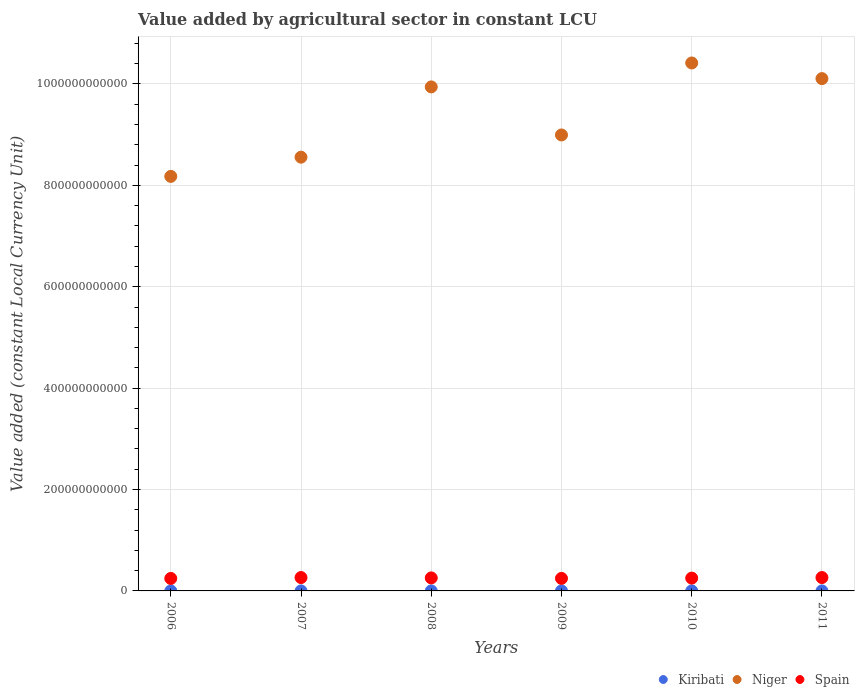What is the value added by agricultural sector in Kiribati in 2010?
Your response must be concise. 3.60e+07. Across all years, what is the maximum value added by agricultural sector in Niger?
Keep it short and to the point. 1.04e+12. Across all years, what is the minimum value added by agricultural sector in Niger?
Give a very brief answer. 8.18e+11. In which year was the value added by agricultural sector in Niger maximum?
Make the answer very short. 2010. In which year was the value added by agricultural sector in Kiribati minimum?
Your answer should be very brief. 2006. What is the total value added by agricultural sector in Kiribati in the graph?
Provide a succinct answer. 2.16e+08. What is the difference between the value added by agricultural sector in Kiribati in 2006 and that in 2008?
Provide a succinct answer. -6.91e+06. What is the difference between the value added by agricultural sector in Niger in 2009 and the value added by agricultural sector in Kiribati in 2007?
Provide a succinct answer. 8.99e+11. What is the average value added by agricultural sector in Niger per year?
Offer a terse response. 9.36e+11. In the year 2008, what is the difference between the value added by agricultural sector in Spain and value added by agricultural sector in Kiribati?
Keep it short and to the point. 2.56e+1. In how many years, is the value added by agricultural sector in Niger greater than 680000000000 LCU?
Offer a very short reply. 6. What is the ratio of the value added by agricultural sector in Kiribati in 2008 to that in 2010?
Provide a short and direct response. 1.04. Is the difference between the value added by agricultural sector in Spain in 2006 and 2008 greater than the difference between the value added by agricultural sector in Kiribati in 2006 and 2008?
Make the answer very short. No. What is the difference between the highest and the lowest value added by agricultural sector in Kiribati?
Your answer should be compact. 9.31e+06. In how many years, is the value added by agricultural sector in Kiribati greater than the average value added by agricultural sector in Kiribati taken over all years?
Your answer should be compact. 3. Is the sum of the value added by agricultural sector in Spain in 2010 and 2011 greater than the maximum value added by agricultural sector in Kiribati across all years?
Make the answer very short. Yes. Is it the case that in every year, the sum of the value added by agricultural sector in Niger and value added by agricultural sector in Kiribati  is greater than the value added by agricultural sector in Spain?
Offer a terse response. Yes. Does the value added by agricultural sector in Spain monotonically increase over the years?
Offer a very short reply. No. How many dotlines are there?
Your answer should be very brief. 3. How many years are there in the graph?
Ensure brevity in your answer.  6. What is the difference between two consecutive major ticks on the Y-axis?
Give a very brief answer. 2.00e+11. Are the values on the major ticks of Y-axis written in scientific E-notation?
Your response must be concise. No. Does the graph contain any zero values?
Give a very brief answer. No. Does the graph contain grids?
Your response must be concise. Yes. Where does the legend appear in the graph?
Ensure brevity in your answer.  Bottom right. How many legend labels are there?
Offer a very short reply. 3. How are the legend labels stacked?
Provide a succinct answer. Horizontal. What is the title of the graph?
Make the answer very short. Value added by agricultural sector in constant LCU. Does "Eritrea" appear as one of the legend labels in the graph?
Provide a succinct answer. No. What is the label or title of the X-axis?
Your response must be concise. Years. What is the label or title of the Y-axis?
Provide a succinct answer. Value added (constant Local Currency Unit). What is the Value added (constant Local Currency Unit) in Kiribati in 2006?
Offer a terse response. 3.07e+07. What is the Value added (constant Local Currency Unit) of Niger in 2006?
Make the answer very short. 8.18e+11. What is the Value added (constant Local Currency Unit) in Spain in 2006?
Provide a succinct answer. 2.46e+1. What is the Value added (constant Local Currency Unit) in Kiribati in 2007?
Offer a terse response. 3.50e+07. What is the Value added (constant Local Currency Unit) of Niger in 2007?
Your answer should be compact. 8.56e+11. What is the Value added (constant Local Currency Unit) of Spain in 2007?
Ensure brevity in your answer.  2.64e+1. What is the Value added (constant Local Currency Unit) of Kiribati in 2008?
Give a very brief answer. 3.76e+07. What is the Value added (constant Local Currency Unit) in Niger in 2008?
Your answer should be very brief. 9.94e+11. What is the Value added (constant Local Currency Unit) in Spain in 2008?
Provide a succinct answer. 2.57e+1. What is the Value added (constant Local Currency Unit) in Kiribati in 2009?
Provide a succinct answer. 3.71e+07. What is the Value added (constant Local Currency Unit) of Niger in 2009?
Give a very brief answer. 8.99e+11. What is the Value added (constant Local Currency Unit) in Spain in 2009?
Offer a very short reply. 2.47e+1. What is the Value added (constant Local Currency Unit) in Kiribati in 2010?
Provide a short and direct response. 3.60e+07. What is the Value added (constant Local Currency Unit) in Niger in 2010?
Make the answer very short. 1.04e+12. What is the Value added (constant Local Currency Unit) in Spain in 2010?
Offer a terse response. 2.53e+1. What is the Value added (constant Local Currency Unit) in Kiribati in 2011?
Give a very brief answer. 4.00e+07. What is the Value added (constant Local Currency Unit) in Niger in 2011?
Give a very brief answer. 1.01e+12. What is the Value added (constant Local Currency Unit) in Spain in 2011?
Ensure brevity in your answer.  2.64e+1. Across all years, what is the maximum Value added (constant Local Currency Unit) of Kiribati?
Your answer should be compact. 4.00e+07. Across all years, what is the maximum Value added (constant Local Currency Unit) of Niger?
Provide a short and direct response. 1.04e+12. Across all years, what is the maximum Value added (constant Local Currency Unit) in Spain?
Give a very brief answer. 2.64e+1. Across all years, what is the minimum Value added (constant Local Currency Unit) of Kiribati?
Your answer should be very brief. 3.07e+07. Across all years, what is the minimum Value added (constant Local Currency Unit) in Niger?
Give a very brief answer. 8.18e+11. Across all years, what is the minimum Value added (constant Local Currency Unit) in Spain?
Provide a short and direct response. 2.46e+1. What is the total Value added (constant Local Currency Unit) of Kiribati in the graph?
Your answer should be compact. 2.16e+08. What is the total Value added (constant Local Currency Unit) in Niger in the graph?
Your answer should be very brief. 5.62e+12. What is the total Value added (constant Local Currency Unit) in Spain in the graph?
Your answer should be very brief. 1.53e+11. What is the difference between the Value added (constant Local Currency Unit) in Kiribati in 2006 and that in 2007?
Your response must be concise. -4.28e+06. What is the difference between the Value added (constant Local Currency Unit) in Niger in 2006 and that in 2007?
Your response must be concise. -3.79e+1. What is the difference between the Value added (constant Local Currency Unit) in Spain in 2006 and that in 2007?
Offer a very short reply. -1.76e+09. What is the difference between the Value added (constant Local Currency Unit) of Kiribati in 2006 and that in 2008?
Make the answer very short. -6.91e+06. What is the difference between the Value added (constant Local Currency Unit) in Niger in 2006 and that in 2008?
Offer a very short reply. -1.77e+11. What is the difference between the Value added (constant Local Currency Unit) in Spain in 2006 and that in 2008?
Provide a succinct answer. -1.05e+09. What is the difference between the Value added (constant Local Currency Unit) in Kiribati in 2006 and that in 2009?
Ensure brevity in your answer.  -6.43e+06. What is the difference between the Value added (constant Local Currency Unit) of Niger in 2006 and that in 2009?
Offer a very short reply. -8.17e+1. What is the difference between the Value added (constant Local Currency Unit) in Spain in 2006 and that in 2009?
Your response must be concise. -1.14e+08. What is the difference between the Value added (constant Local Currency Unit) in Kiribati in 2006 and that in 2010?
Make the answer very short. -5.31e+06. What is the difference between the Value added (constant Local Currency Unit) of Niger in 2006 and that in 2010?
Offer a terse response. -2.24e+11. What is the difference between the Value added (constant Local Currency Unit) in Spain in 2006 and that in 2010?
Your answer should be very brief. -6.43e+08. What is the difference between the Value added (constant Local Currency Unit) in Kiribati in 2006 and that in 2011?
Offer a very short reply. -9.31e+06. What is the difference between the Value added (constant Local Currency Unit) of Niger in 2006 and that in 2011?
Your answer should be very brief. -1.93e+11. What is the difference between the Value added (constant Local Currency Unit) in Spain in 2006 and that in 2011?
Give a very brief answer. -1.76e+09. What is the difference between the Value added (constant Local Currency Unit) in Kiribati in 2007 and that in 2008?
Make the answer very short. -2.63e+06. What is the difference between the Value added (constant Local Currency Unit) in Niger in 2007 and that in 2008?
Offer a terse response. -1.39e+11. What is the difference between the Value added (constant Local Currency Unit) of Spain in 2007 and that in 2008?
Provide a short and direct response. 7.15e+08. What is the difference between the Value added (constant Local Currency Unit) of Kiribati in 2007 and that in 2009?
Offer a terse response. -2.15e+06. What is the difference between the Value added (constant Local Currency Unit) of Niger in 2007 and that in 2009?
Provide a short and direct response. -4.38e+1. What is the difference between the Value added (constant Local Currency Unit) of Spain in 2007 and that in 2009?
Make the answer very short. 1.65e+09. What is the difference between the Value added (constant Local Currency Unit) in Kiribati in 2007 and that in 2010?
Your response must be concise. -1.02e+06. What is the difference between the Value added (constant Local Currency Unit) of Niger in 2007 and that in 2010?
Your response must be concise. -1.86e+11. What is the difference between the Value added (constant Local Currency Unit) in Spain in 2007 and that in 2010?
Offer a very short reply. 1.12e+09. What is the difference between the Value added (constant Local Currency Unit) of Kiribati in 2007 and that in 2011?
Make the answer very short. -5.02e+06. What is the difference between the Value added (constant Local Currency Unit) of Niger in 2007 and that in 2011?
Your answer should be very brief. -1.55e+11. What is the difference between the Value added (constant Local Currency Unit) of Kiribati in 2008 and that in 2009?
Offer a very short reply. 4.78e+05. What is the difference between the Value added (constant Local Currency Unit) in Niger in 2008 and that in 2009?
Give a very brief answer. 9.48e+1. What is the difference between the Value added (constant Local Currency Unit) of Spain in 2008 and that in 2009?
Your response must be concise. 9.32e+08. What is the difference between the Value added (constant Local Currency Unit) in Kiribati in 2008 and that in 2010?
Provide a succinct answer. 1.60e+06. What is the difference between the Value added (constant Local Currency Unit) of Niger in 2008 and that in 2010?
Keep it short and to the point. -4.72e+1. What is the difference between the Value added (constant Local Currency Unit) in Spain in 2008 and that in 2010?
Offer a very short reply. 4.03e+08. What is the difference between the Value added (constant Local Currency Unit) in Kiribati in 2008 and that in 2011?
Your response must be concise. -2.40e+06. What is the difference between the Value added (constant Local Currency Unit) of Niger in 2008 and that in 2011?
Offer a very short reply. -1.64e+1. What is the difference between the Value added (constant Local Currency Unit) in Spain in 2008 and that in 2011?
Give a very brief answer. -7.17e+08. What is the difference between the Value added (constant Local Currency Unit) of Kiribati in 2009 and that in 2010?
Offer a very short reply. 1.13e+06. What is the difference between the Value added (constant Local Currency Unit) of Niger in 2009 and that in 2010?
Your answer should be compact. -1.42e+11. What is the difference between the Value added (constant Local Currency Unit) in Spain in 2009 and that in 2010?
Ensure brevity in your answer.  -5.29e+08. What is the difference between the Value added (constant Local Currency Unit) in Kiribati in 2009 and that in 2011?
Your answer should be very brief. -2.87e+06. What is the difference between the Value added (constant Local Currency Unit) of Niger in 2009 and that in 2011?
Ensure brevity in your answer.  -1.11e+11. What is the difference between the Value added (constant Local Currency Unit) of Spain in 2009 and that in 2011?
Offer a terse response. -1.65e+09. What is the difference between the Value added (constant Local Currency Unit) in Kiribati in 2010 and that in 2011?
Provide a short and direct response. -4.00e+06. What is the difference between the Value added (constant Local Currency Unit) in Niger in 2010 and that in 2011?
Offer a terse response. 3.09e+1. What is the difference between the Value added (constant Local Currency Unit) in Spain in 2010 and that in 2011?
Offer a terse response. -1.12e+09. What is the difference between the Value added (constant Local Currency Unit) of Kiribati in 2006 and the Value added (constant Local Currency Unit) of Niger in 2007?
Offer a terse response. -8.56e+11. What is the difference between the Value added (constant Local Currency Unit) of Kiribati in 2006 and the Value added (constant Local Currency Unit) of Spain in 2007?
Keep it short and to the point. -2.63e+1. What is the difference between the Value added (constant Local Currency Unit) of Niger in 2006 and the Value added (constant Local Currency Unit) of Spain in 2007?
Provide a succinct answer. 7.91e+11. What is the difference between the Value added (constant Local Currency Unit) in Kiribati in 2006 and the Value added (constant Local Currency Unit) in Niger in 2008?
Offer a very short reply. -9.94e+11. What is the difference between the Value added (constant Local Currency Unit) in Kiribati in 2006 and the Value added (constant Local Currency Unit) in Spain in 2008?
Offer a very short reply. -2.56e+1. What is the difference between the Value added (constant Local Currency Unit) in Niger in 2006 and the Value added (constant Local Currency Unit) in Spain in 2008?
Ensure brevity in your answer.  7.92e+11. What is the difference between the Value added (constant Local Currency Unit) in Kiribati in 2006 and the Value added (constant Local Currency Unit) in Niger in 2009?
Give a very brief answer. -8.99e+11. What is the difference between the Value added (constant Local Currency Unit) of Kiribati in 2006 and the Value added (constant Local Currency Unit) of Spain in 2009?
Offer a terse response. -2.47e+1. What is the difference between the Value added (constant Local Currency Unit) in Niger in 2006 and the Value added (constant Local Currency Unit) in Spain in 2009?
Offer a very short reply. 7.93e+11. What is the difference between the Value added (constant Local Currency Unit) of Kiribati in 2006 and the Value added (constant Local Currency Unit) of Niger in 2010?
Keep it short and to the point. -1.04e+12. What is the difference between the Value added (constant Local Currency Unit) in Kiribati in 2006 and the Value added (constant Local Currency Unit) in Spain in 2010?
Give a very brief answer. -2.52e+1. What is the difference between the Value added (constant Local Currency Unit) of Niger in 2006 and the Value added (constant Local Currency Unit) of Spain in 2010?
Offer a terse response. 7.92e+11. What is the difference between the Value added (constant Local Currency Unit) of Kiribati in 2006 and the Value added (constant Local Currency Unit) of Niger in 2011?
Ensure brevity in your answer.  -1.01e+12. What is the difference between the Value added (constant Local Currency Unit) of Kiribati in 2006 and the Value added (constant Local Currency Unit) of Spain in 2011?
Offer a very short reply. -2.63e+1. What is the difference between the Value added (constant Local Currency Unit) in Niger in 2006 and the Value added (constant Local Currency Unit) in Spain in 2011?
Offer a very short reply. 7.91e+11. What is the difference between the Value added (constant Local Currency Unit) of Kiribati in 2007 and the Value added (constant Local Currency Unit) of Niger in 2008?
Give a very brief answer. -9.94e+11. What is the difference between the Value added (constant Local Currency Unit) of Kiribati in 2007 and the Value added (constant Local Currency Unit) of Spain in 2008?
Provide a succinct answer. -2.56e+1. What is the difference between the Value added (constant Local Currency Unit) of Niger in 2007 and the Value added (constant Local Currency Unit) of Spain in 2008?
Offer a very short reply. 8.30e+11. What is the difference between the Value added (constant Local Currency Unit) in Kiribati in 2007 and the Value added (constant Local Currency Unit) in Niger in 2009?
Your answer should be very brief. -8.99e+11. What is the difference between the Value added (constant Local Currency Unit) in Kiribati in 2007 and the Value added (constant Local Currency Unit) in Spain in 2009?
Your answer should be very brief. -2.47e+1. What is the difference between the Value added (constant Local Currency Unit) of Niger in 2007 and the Value added (constant Local Currency Unit) of Spain in 2009?
Give a very brief answer. 8.31e+11. What is the difference between the Value added (constant Local Currency Unit) in Kiribati in 2007 and the Value added (constant Local Currency Unit) in Niger in 2010?
Provide a succinct answer. -1.04e+12. What is the difference between the Value added (constant Local Currency Unit) in Kiribati in 2007 and the Value added (constant Local Currency Unit) in Spain in 2010?
Offer a very short reply. -2.52e+1. What is the difference between the Value added (constant Local Currency Unit) in Niger in 2007 and the Value added (constant Local Currency Unit) in Spain in 2010?
Offer a very short reply. 8.30e+11. What is the difference between the Value added (constant Local Currency Unit) in Kiribati in 2007 and the Value added (constant Local Currency Unit) in Niger in 2011?
Give a very brief answer. -1.01e+12. What is the difference between the Value added (constant Local Currency Unit) of Kiribati in 2007 and the Value added (constant Local Currency Unit) of Spain in 2011?
Provide a succinct answer. -2.63e+1. What is the difference between the Value added (constant Local Currency Unit) in Niger in 2007 and the Value added (constant Local Currency Unit) in Spain in 2011?
Your response must be concise. 8.29e+11. What is the difference between the Value added (constant Local Currency Unit) in Kiribati in 2008 and the Value added (constant Local Currency Unit) in Niger in 2009?
Offer a terse response. -8.99e+11. What is the difference between the Value added (constant Local Currency Unit) of Kiribati in 2008 and the Value added (constant Local Currency Unit) of Spain in 2009?
Your answer should be compact. -2.47e+1. What is the difference between the Value added (constant Local Currency Unit) of Niger in 2008 and the Value added (constant Local Currency Unit) of Spain in 2009?
Your answer should be very brief. 9.69e+11. What is the difference between the Value added (constant Local Currency Unit) in Kiribati in 2008 and the Value added (constant Local Currency Unit) in Niger in 2010?
Your answer should be compact. -1.04e+12. What is the difference between the Value added (constant Local Currency Unit) in Kiribati in 2008 and the Value added (constant Local Currency Unit) in Spain in 2010?
Make the answer very short. -2.52e+1. What is the difference between the Value added (constant Local Currency Unit) of Niger in 2008 and the Value added (constant Local Currency Unit) of Spain in 2010?
Offer a terse response. 9.69e+11. What is the difference between the Value added (constant Local Currency Unit) in Kiribati in 2008 and the Value added (constant Local Currency Unit) in Niger in 2011?
Your answer should be very brief. -1.01e+12. What is the difference between the Value added (constant Local Currency Unit) of Kiribati in 2008 and the Value added (constant Local Currency Unit) of Spain in 2011?
Your answer should be compact. -2.63e+1. What is the difference between the Value added (constant Local Currency Unit) in Niger in 2008 and the Value added (constant Local Currency Unit) in Spain in 2011?
Make the answer very short. 9.68e+11. What is the difference between the Value added (constant Local Currency Unit) in Kiribati in 2009 and the Value added (constant Local Currency Unit) in Niger in 2010?
Provide a succinct answer. -1.04e+12. What is the difference between the Value added (constant Local Currency Unit) of Kiribati in 2009 and the Value added (constant Local Currency Unit) of Spain in 2010?
Your response must be concise. -2.52e+1. What is the difference between the Value added (constant Local Currency Unit) in Niger in 2009 and the Value added (constant Local Currency Unit) in Spain in 2010?
Give a very brief answer. 8.74e+11. What is the difference between the Value added (constant Local Currency Unit) in Kiribati in 2009 and the Value added (constant Local Currency Unit) in Niger in 2011?
Offer a terse response. -1.01e+12. What is the difference between the Value added (constant Local Currency Unit) in Kiribati in 2009 and the Value added (constant Local Currency Unit) in Spain in 2011?
Your answer should be compact. -2.63e+1. What is the difference between the Value added (constant Local Currency Unit) of Niger in 2009 and the Value added (constant Local Currency Unit) of Spain in 2011?
Your answer should be very brief. 8.73e+11. What is the difference between the Value added (constant Local Currency Unit) of Kiribati in 2010 and the Value added (constant Local Currency Unit) of Niger in 2011?
Provide a short and direct response. -1.01e+12. What is the difference between the Value added (constant Local Currency Unit) in Kiribati in 2010 and the Value added (constant Local Currency Unit) in Spain in 2011?
Ensure brevity in your answer.  -2.63e+1. What is the difference between the Value added (constant Local Currency Unit) in Niger in 2010 and the Value added (constant Local Currency Unit) in Spain in 2011?
Make the answer very short. 1.02e+12. What is the average Value added (constant Local Currency Unit) of Kiribati per year?
Your answer should be very brief. 3.61e+07. What is the average Value added (constant Local Currency Unit) of Niger per year?
Offer a very short reply. 9.36e+11. What is the average Value added (constant Local Currency Unit) of Spain per year?
Your answer should be compact. 2.55e+1. In the year 2006, what is the difference between the Value added (constant Local Currency Unit) in Kiribati and Value added (constant Local Currency Unit) in Niger?
Your answer should be very brief. -8.18e+11. In the year 2006, what is the difference between the Value added (constant Local Currency Unit) of Kiribati and Value added (constant Local Currency Unit) of Spain?
Ensure brevity in your answer.  -2.46e+1. In the year 2006, what is the difference between the Value added (constant Local Currency Unit) of Niger and Value added (constant Local Currency Unit) of Spain?
Provide a short and direct response. 7.93e+11. In the year 2007, what is the difference between the Value added (constant Local Currency Unit) of Kiribati and Value added (constant Local Currency Unit) of Niger?
Make the answer very short. -8.56e+11. In the year 2007, what is the difference between the Value added (constant Local Currency Unit) of Kiribati and Value added (constant Local Currency Unit) of Spain?
Offer a terse response. -2.63e+1. In the year 2007, what is the difference between the Value added (constant Local Currency Unit) in Niger and Value added (constant Local Currency Unit) in Spain?
Provide a short and direct response. 8.29e+11. In the year 2008, what is the difference between the Value added (constant Local Currency Unit) of Kiribati and Value added (constant Local Currency Unit) of Niger?
Ensure brevity in your answer.  -9.94e+11. In the year 2008, what is the difference between the Value added (constant Local Currency Unit) in Kiribati and Value added (constant Local Currency Unit) in Spain?
Give a very brief answer. -2.56e+1. In the year 2008, what is the difference between the Value added (constant Local Currency Unit) of Niger and Value added (constant Local Currency Unit) of Spain?
Offer a terse response. 9.69e+11. In the year 2009, what is the difference between the Value added (constant Local Currency Unit) of Kiribati and Value added (constant Local Currency Unit) of Niger?
Your response must be concise. -8.99e+11. In the year 2009, what is the difference between the Value added (constant Local Currency Unit) in Kiribati and Value added (constant Local Currency Unit) in Spain?
Provide a succinct answer. -2.47e+1. In the year 2009, what is the difference between the Value added (constant Local Currency Unit) of Niger and Value added (constant Local Currency Unit) of Spain?
Offer a very short reply. 8.75e+11. In the year 2010, what is the difference between the Value added (constant Local Currency Unit) in Kiribati and Value added (constant Local Currency Unit) in Niger?
Your answer should be compact. -1.04e+12. In the year 2010, what is the difference between the Value added (constant Local Currency Unit) of Kiribati and Value added (constant Local Currency Unit) of Spain?
Your answer should be compact. -2.52e+1. In the year 2010, what is the difference between the Value added (constant Local Currency Unit) of Niger and Value added (constant Local Currency Unit) of Spain?
Your answer should be very brief. 1.02e+12. In the year 2011, what is the difference between the Value added (constant Local Currency Unit) in Kiribati and Value added (constant Local Currency Unit) in Niger?
Give a very brief answer. -1.01e+12. In the year 2011, what is the difference between the Value added (constant Local Currency Unit) of Kiribati and Value added (constant Local Currency Unit) of Spain?
Provide a short and direct response. -2.63e+1. In the year 2011, what is the difference between the Value added (constant Local Currency Unit) in Niger and Value added (constant Local Currency Unit) in Spain?
Provide a succinct answer. 9.84e+11. What is the ratio of the Value added (constant Local Currency Unit) of Kiribati in 2006 to that in 2007?
Offer a very short reply. 0.88. What is the ratio of the Value added (constant Local Currency Unit) in Niger in 2006 to that in 2007?
Provide a short and direct response. 0.96. What is the ratio of the Value added (constant Local Currency Unit) in Spain in 2006 to that in 2007?
Your answer should be very brief. 0.93. What is the ratio of the Value added (constant Local Currency Unit) of Kiribati in 2006 to that in 2008?
Your answer should be compact. 0.82. What is the ratio of the Value added (constant Local Currency Unit) in Niger in 2006 to that in 2008?
Your answer should be very brief. 0.82. What is the ratio of the Value added (constant Local Currency Unit) in Spain in 2006 to that in 2008?
Offer a terse response. 0.96. What is the ratio of the Value added (constant Local Currency Unit) of Kiribati in 2006 to that in 2009?
Keep it short and to the point. 0.83. What is the ratio of the Value added (constant Local Currency Unit) of Niger in 2006 to that in 2009?
Make the answer very short. 0.91. What is the ratio of the Value added (constant Local Currency Unit) of Kiribati in 2006 to that in 2010?
Your answer should be very brief. 0.85. What is the ratio of the Value added (constant Local Currency Unit) in Niger in 2006 to that in 2010?
Your answer should be very brief. 0.79. What is the ratio of the Value added (constant Local Currency Unit) of Spain in 2006 to that in 2010?
Offer a very short reply. 0.97. What is the ratio of the Value added (constant Local Currency Unit) in Kiribati in 2006 to that in 2011?
Give a very brief answer. 0.77. What is the ratio of the Value added (constant Local Currency Unit) in Niger in 2006 to that in 2011?
Make the answer very short. 0.81. What is the ratio of the Value added (constant Local Currency Unit) in Spain in 2006 to that in 2011?
Provide a short and direct response. 0.93. What is the ratio of the Value added (constant Local Currency Unit) of Kiribati in 2007 to that in 2008?
Keep it short and to the point. 0.93. What is the ratio of the Value added (constant Local Currency Unit) in Niger in 2007 to that in 2008?
Provide a short and direct response. 0.86. What is the ratio of the Value added (constant Local Currency Unit) in Spain in 2007 to that in 2008?
Provide a short and direct response. 1.03. What is the ratio of the Value added (constant Local Currency Unit) of Kiribati in 2007 to that in 2009?
Offer a terse response. 0.94. What is the ratio of the Value added (constant Local Currency Unit) of Niger in 2007 to that in 2009?
Offer a very short reply. 0.95. What is the ratio of the Value added (constant Local Currency Unit) of Spain in 2007 to that in 2009?
Provide a short and direct response. 1.07. What is the ratio of the Value added (constant Local Currency Unit) of Kiribati in 2007 to that in 2010?
Ensure brevity in your answer.  0.97. What is the ratio of the Value added (constant Local Currency Unit) in Niger in 2007 to that in 2010?
Make the answer very short. 0.82. What is the ratio of the Value added (constant Local Currency Unit) of Spain in 2007 to that in 2010?
Your answer should be very brief. 1.04. What is the ratio of the Value added (constant Local Currency Unit) in Kiribati in 2007 to that in 2011?
Ensure brevity in your answer.  0.87. What is the ratio of the Value added (constant Local Currency Unit) in Niger in 2007 to that in 2011?
Make the answer very short. 0.85. What is the ratio of the Value added (constant Local Currency Unit) in Spain in 2007 to that in 2011?
Make the answer very short. 1. What is the ratio of the Value added (constant Local Currency Unit) in Kiribati in 2008 to that in 2009?
Your answer should be compact. 1.01. What is the ratio of the Value added (constant Local Currency Unit) in Niger in 2008 to that in 2009?
Your response must be concise. 1.11. What is the ratio of the Value added (constant Local Currency Unit) of Spain in 2008 to that in 2009?
Make the answer very short. 1.04. What is the ratio of the Value added (constant Local Currency Unit) in Kiribati in 2008 to that in 2010?
Your answer should be very brief. 1.04. What is the ratio of the Value added (constant Local Currency Unit) in Niger in 2008 to that in 2010?
Your answer should be compact. 0.95. What is the ratio of the Value added (constant Local Currency Unit) of Spain in 2008 to that in 2010?
Provide a succinct answer. 1.02. What is the ratio of the Value added (constant Local Currency Unit) in Kiribati in 2008 to that in 2011?
Make the answer very short. 0.94. What is the ratio of the Value added (constant Local Currency Unit) in Niger in 2008 to that in 2011?
Your response must be concise. 0.98. What is the ratio of the Value added (constant Local Currency Unit) of Spain in 2008 to that in 2011?
Give a very brief answer. 0.97. What is the ratio of the Value added (constant Local Currency Unit) of Kiribati in 2009 to that in 2010?
Ensure brevity in your answer.  1.03. What is the ratio of the Value added (constant Local Currency Unit) of Niger in 2009 to that in 2010?
Keep it short and to the point. 0.86. What is the ratio of the Value added (constant Local Currency Unit) of Spain in 2009 to that in 2010?
Provide a short and direct response. 0.98. What is the ratio of the Value added (constant Local Currency Unit) in Kiribati in 2009 to that in 2011?
Give a very brief answer. 0.93. What is the ratio of the Value added (constant Local Currency Unit) in Niger in 2009 to that in 2011?
Your answer should be very brief. 0.89. What is the ratio of the Value added (constant Local Currency Unit) in Spain in 2009 to that in 2011?
Offer a terse response. 0.94. What is the ratio of the Value added (constant Local Currency Unit) in Niger in 2010 to that in 2011?
Ensure brevity in your answer.  1.03. What is the ratio of the Value added (constant Local Currency Unit) in Spain in 2010 to that in 2011?
Ensure brevity in your answer.  0.96. What is the difference between the highest and the second highest Value added (constant Local Currency Unit) in Kiribati?
Offer a very short reply. 2.40e+06. What is the difference between the highest and the second highest Value added (constant Local Currency Unit) of Niger?
Offer a very short reply. 3.09e+1. What is the difference between the highest and the second highest Value added (constant Local Currency Unit) in Spain?
Ensure brevity in your answer.  2.00e+06. What is the difference between the highest and the lowest Value added (constant Local Currency Unit) in Kiribati?
Your answer should be very brief. 9.31e+06. What is the difference between the highest and the lowest Value added (constant Local Currency Unit) in Niger?
Your answer should be compact. 2.24e+11. What is the difference between the highest and the lowest Value added (constant Local Currency Unit) of Spain?
Make the answer very short. 1.76e+09. 